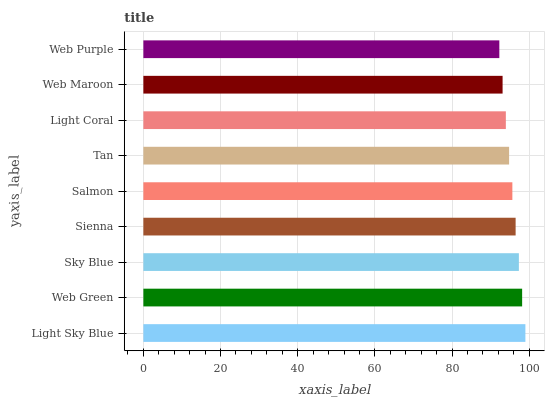Is Web Purple the minimum?
Answer yes or no. Yes. Is Light Sky Blue the maximum?
Answer yes or no. Yes. Is Web Green the minimum?
Answer yes or no. No. Is Web Green the maximum?
Answer yes or no. No. Is Light Sky Blue greater than Web Green?
Answer yes or no. Yes. Is Web Green less than Light Sky Blue?
Answer yes or no. Yes. Is Web Green greater than Light Sky Blue?
Answer yes or no. No. Is Light Sky Blue less than Web Green?
Answer yes or no. No. Is Salmon the high median?
Answer yes or no. Yes. Is Salmon the low median?
Answer yes or no. Yes. Is Sky Blue the high median?
Answer yes or no. No. Is Web Purple the low median?
Answer yes or no. No. 